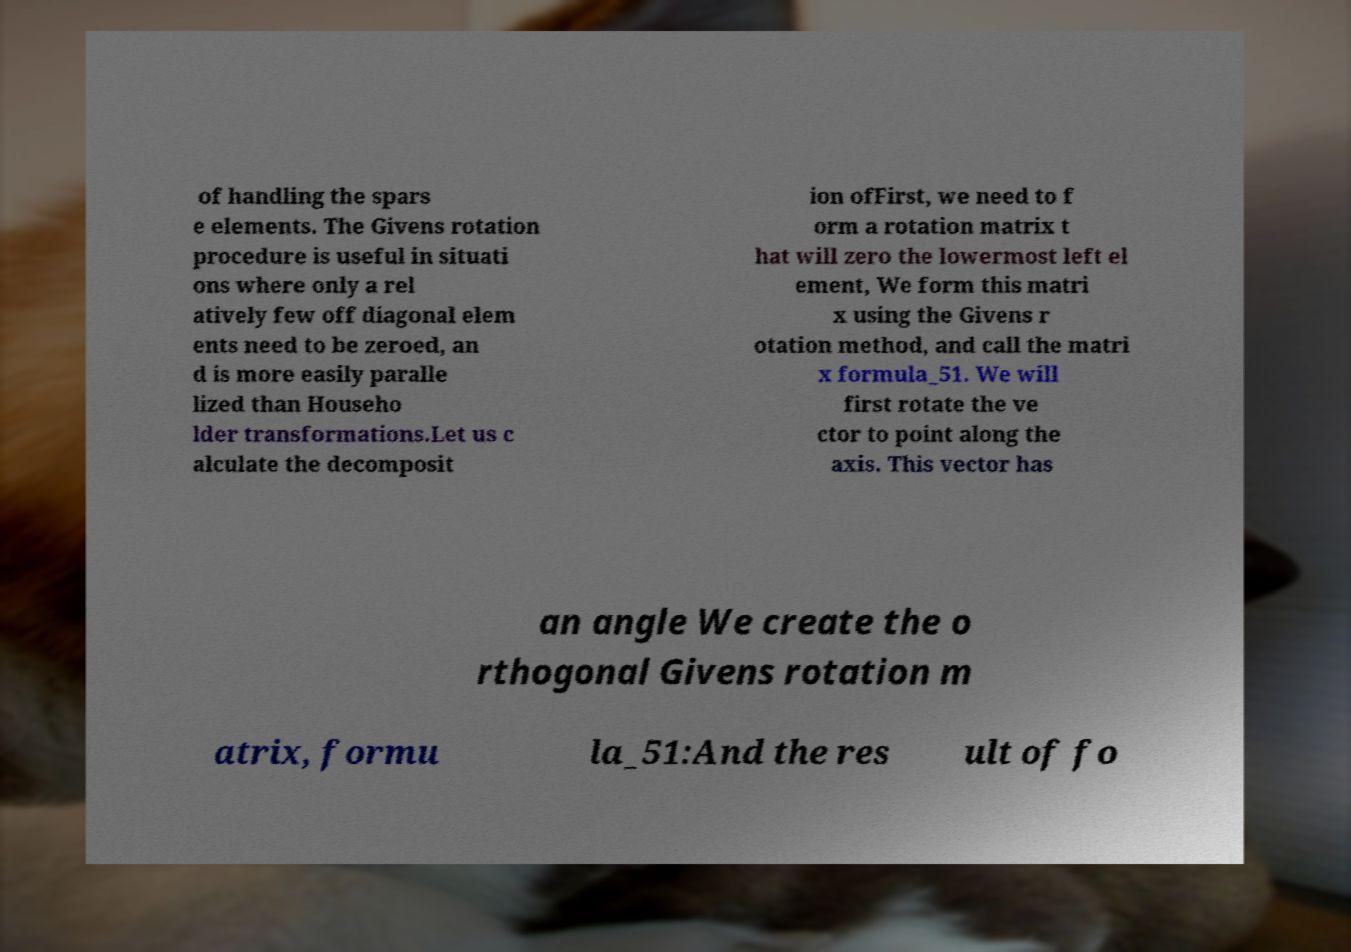Can you accurately transcribe the text from the provided image for me? of handling the spars e elements. The Givens rotation procedure is useful in situati ons where only a rel atively few off diagonal elem ents need to be zeroed, an d is more easily paralle lized than Househo lder transformations.Let us c alculate the decomposit ion ofFirst, we need to f orm a rotation matrix t hat will zero the lowermost left el ement, We form this matri x using the Givens r otation method, and call the matri x formula_51. We will first rotate the ve ctor to point along the axis. This vector has an angle We create the o rthogonal Givens rotation m atrix, formu la_51:And the res ult of fo 